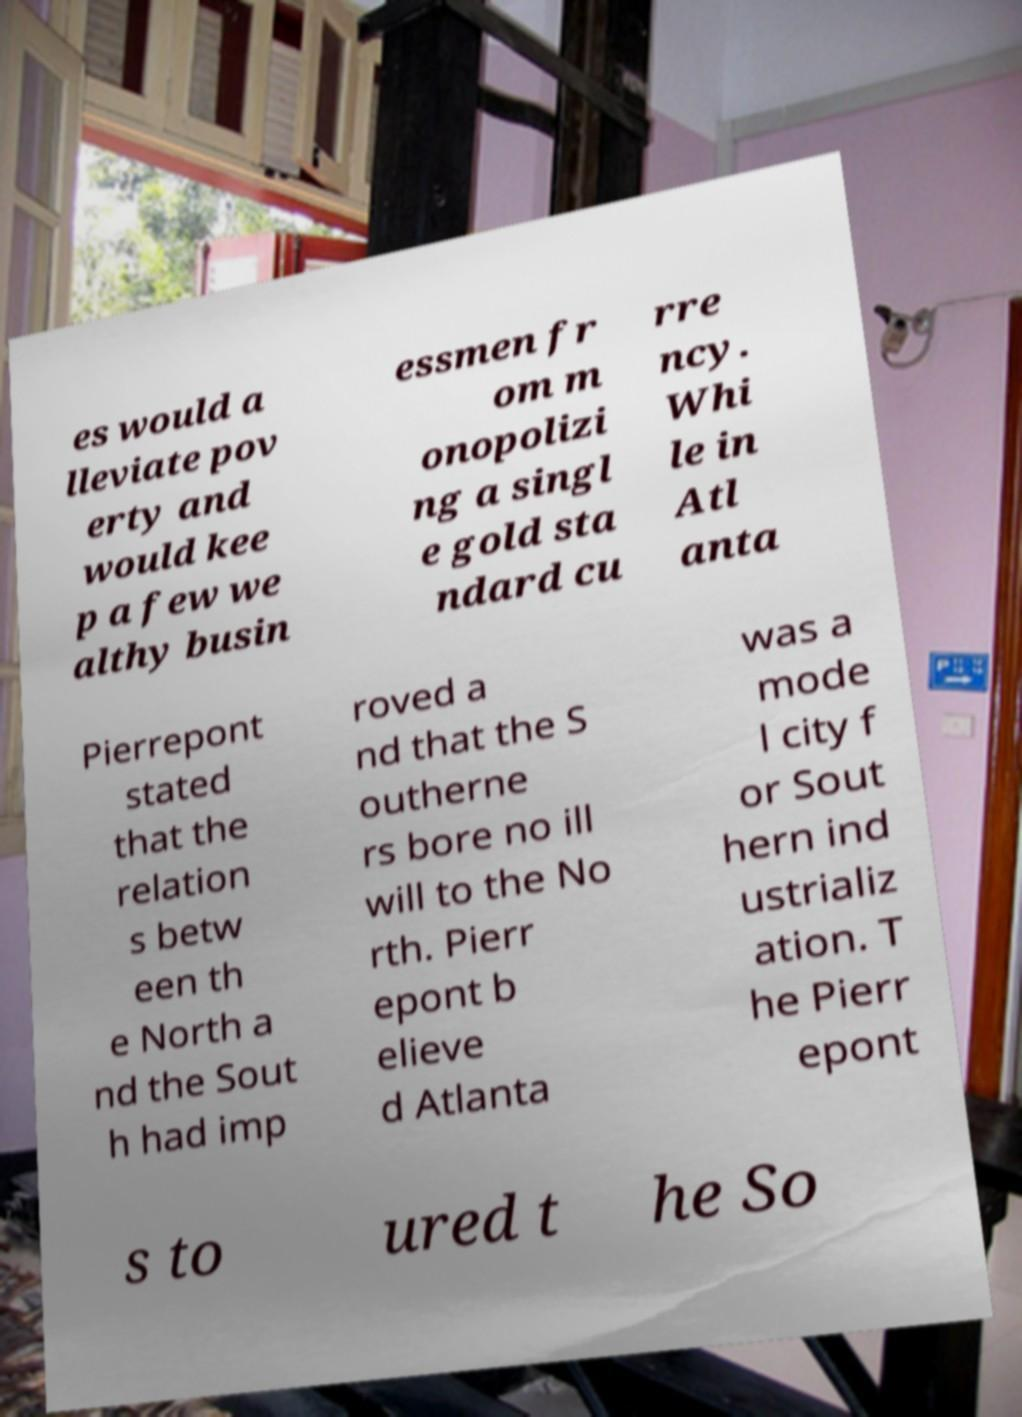What messages or text are displayed in this image? I need them in a readable, typed format. es would a lleviate pov erty and would kee p a few we althy busin essmen fr om m onopolizi ng a singl e gold sta ndard cu rre ncy. Whi le in Atl anta Pierrepont stated that the relation s betw een th e North a nd the Sout h had imp roved a nd that the S outherne rs bore no ill will to the No rth. Pierr epont b elieve d Atlanta was a mode l city f or Sout hern ind ustrializ ation. T he Pierr epont s to ured t he So 